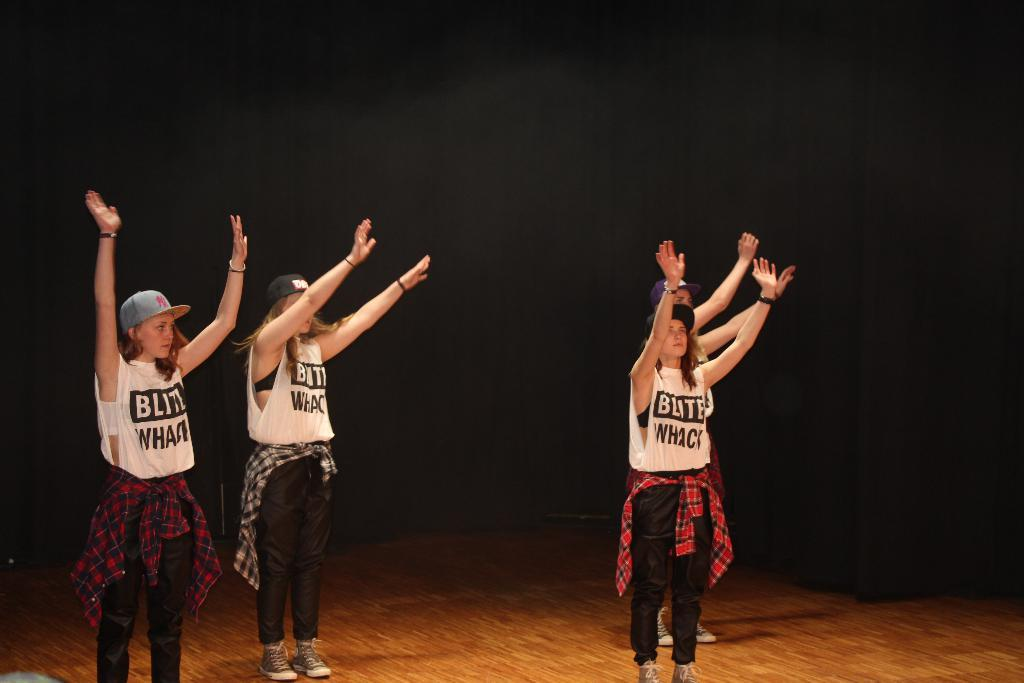How many women are in the image? There are four women in the image. What are the women doing in the image? The women are standing. What are the women wearing in the image? The women are wearing dresses of the same color. What is the color of the floor in the image? The floor is brown in color. How would you describe the lighting in the image? The background is dark. Can you see any blood on the floor in the image? There is no blood visible on the floor in the image. Is there a porter assisting the women in the image? There is no porter present in the image. 